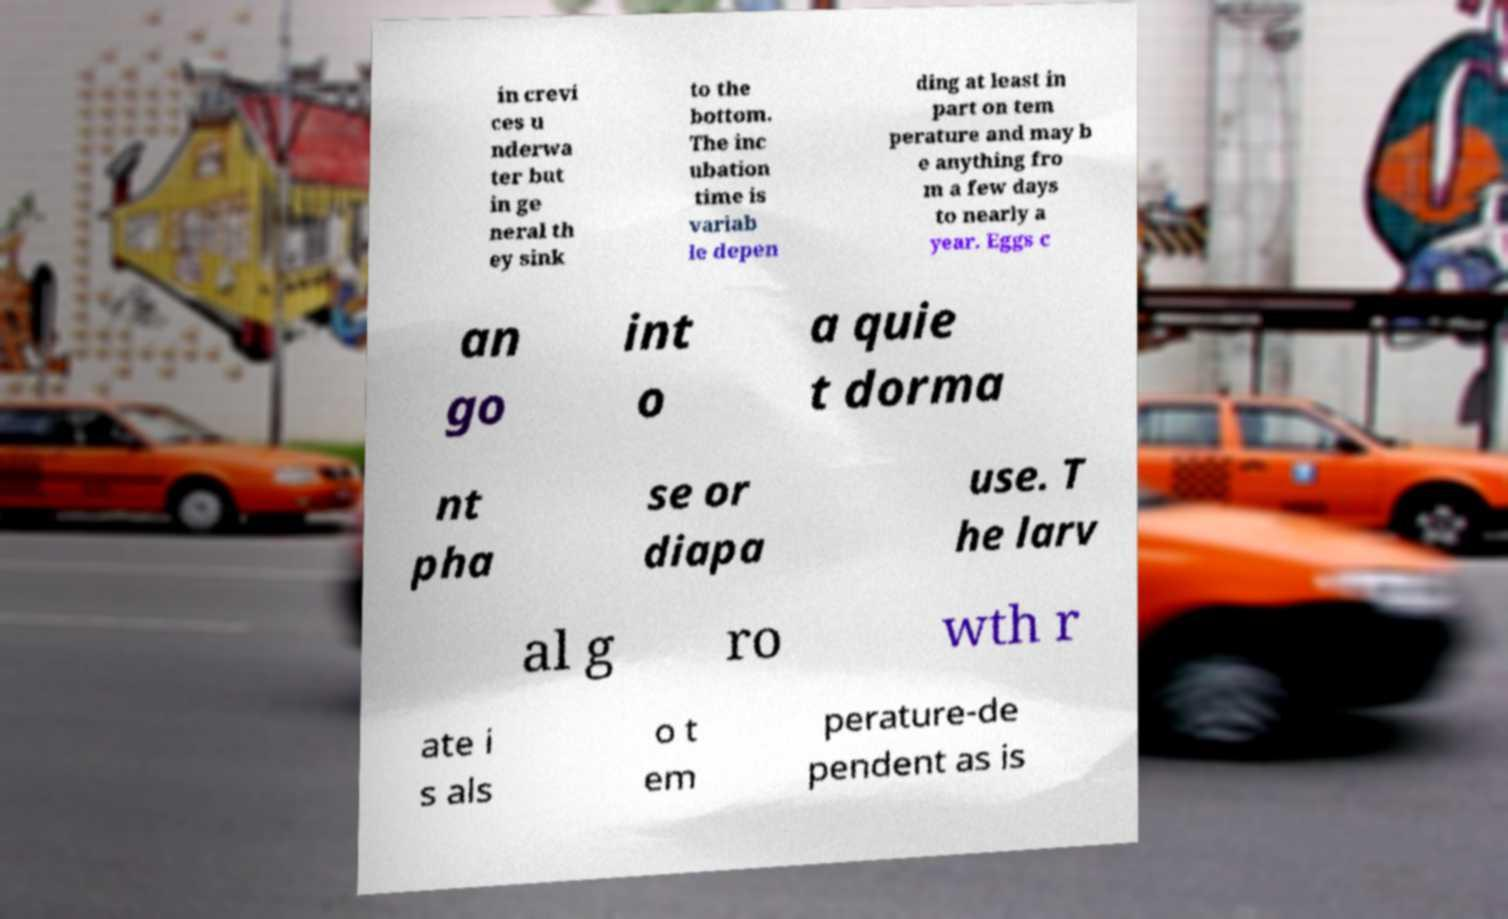Could you assist in decoding the text presented in this image and type it out clearly? in crevi ces u nderwa ter but in ge neral th ey sink to the bottom. The inc ubation time is variab le depen ding at least in part on tem perature and may b e anything fro m a few days to nearly a year. Eggs c an go int o a quie t dorma nt pha se or diapa use. T he larv al g ro wth r ate i s als o t em perature-de pendent as is 